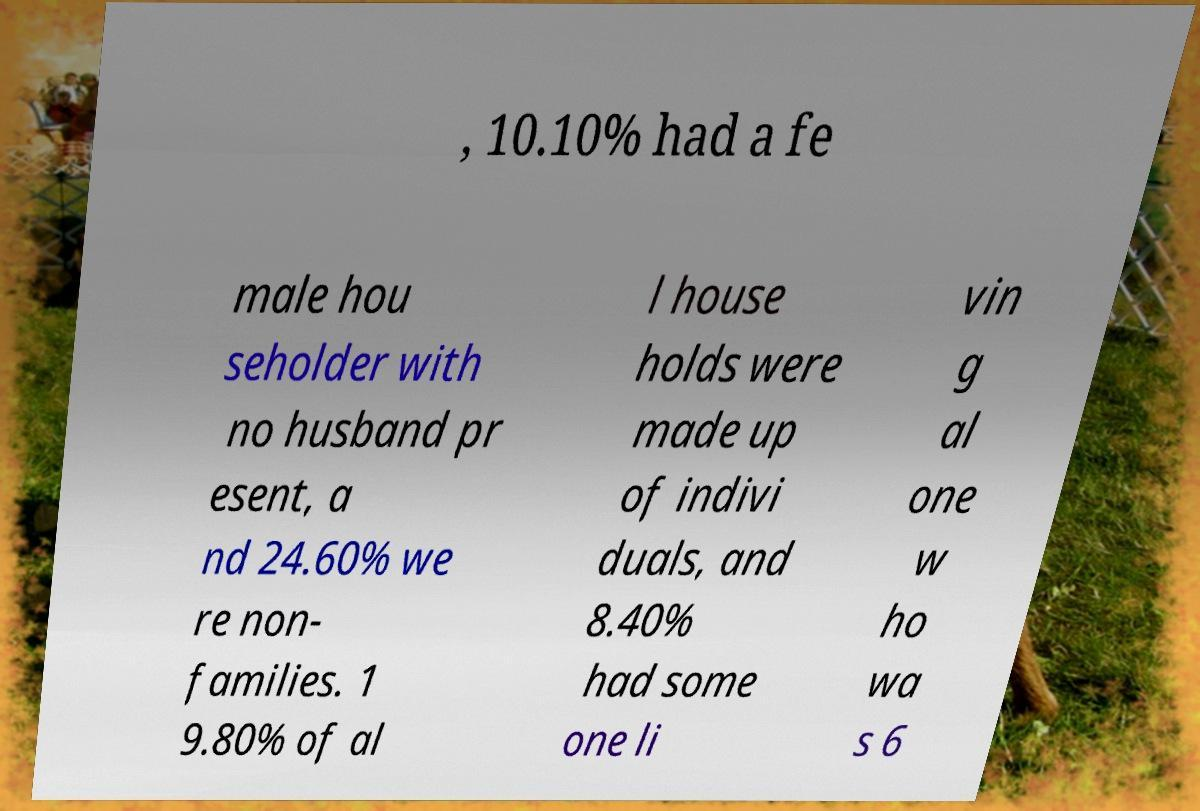What messages or text are displayed in this image? I need them in a readable, typed format. , 10.10% had a fe male hou seholder with no husband pr esent, a nd 24.60% we re non- families. 1 9.80% of al l house holds were made up of indivi duals, and 8.40% had some one li vin g al one w ho wa s 6 